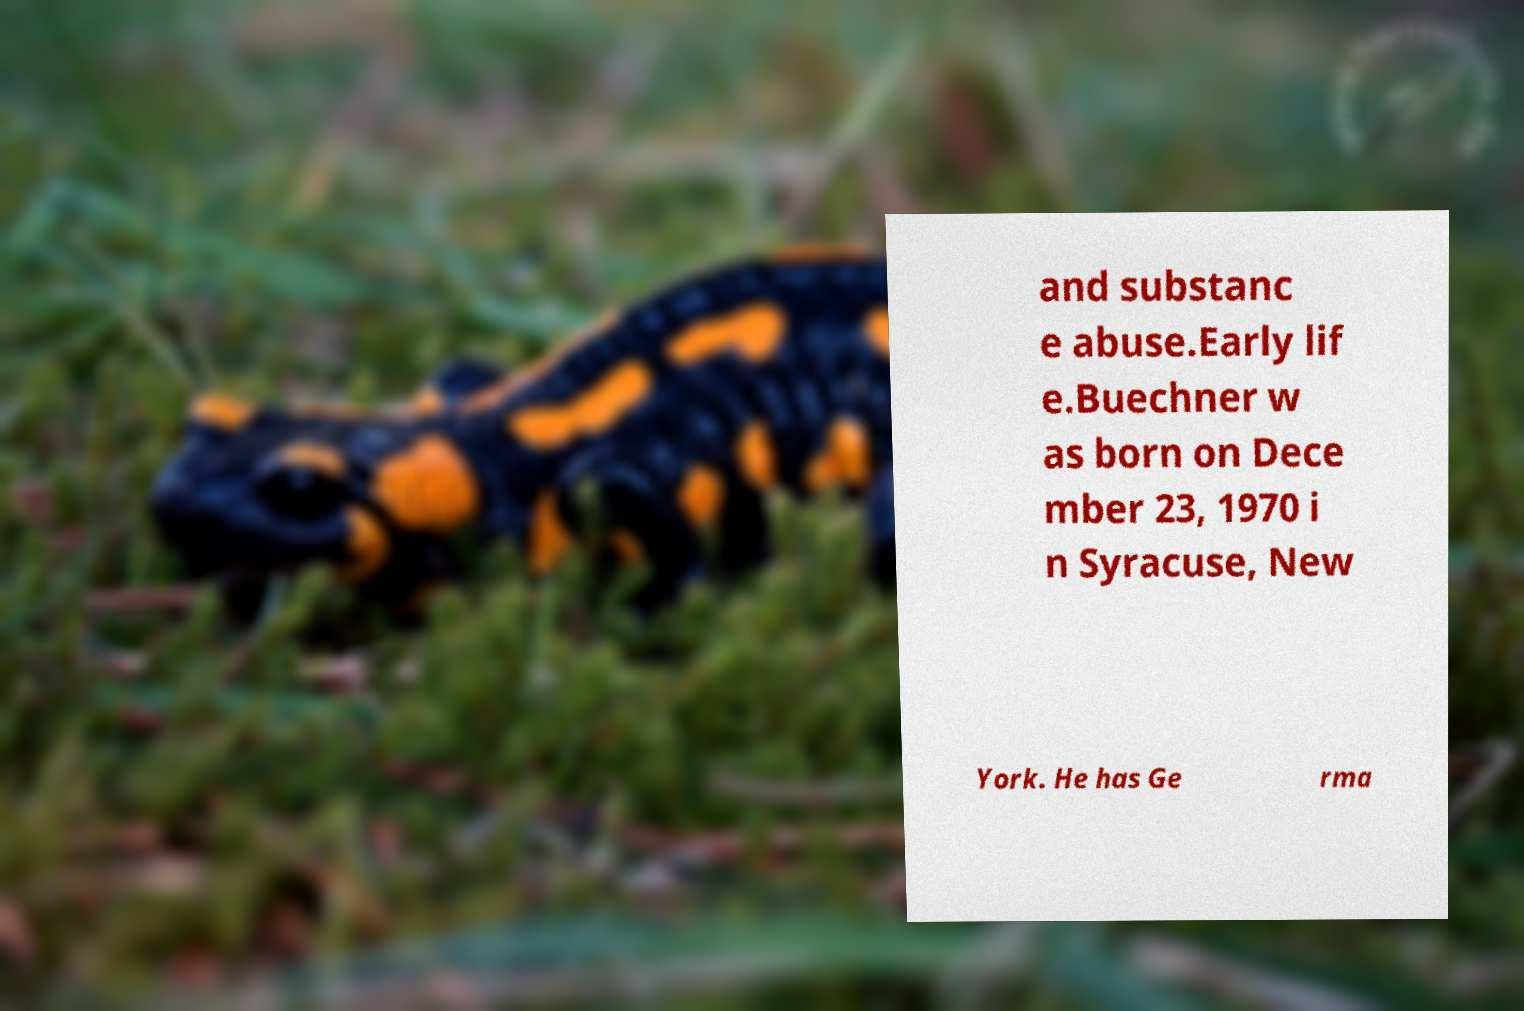Could you extract and type out the text from this image? and substanc e abuse.Early lif e.Buechner w as born on Dece mber 23, 1970 i n Syracuse, New York. He has Ge rma 